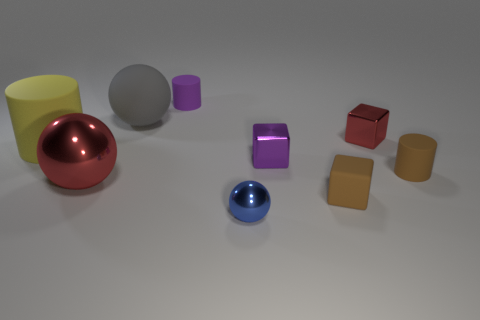Is the number of large shiny spheres behind the big gray sphere greater than the number of blue balls that are behind the tiny blue sphere?
Offer a very short reply. No. What number of things are matte objects behind the big yellow rubber thing or small brown shiny blocks?
Give a very brief answer. 2. The large red thing that is made of the same material as the blue sphere is what shape?
Your answer should be very brief. Sphere. Is there any other thing that is the same shape as the small red thing?
Ensure brevity in your answer.  Yes. What color is the cylinder that is in front of the big gray matte sphere and right of the gray matte ball?
Keep it short and to the point. Brown. What number of spheres are either big red metallic things or yellow rubber things?
Keep it short and to the point. 1. How many purple metal blocks are the same size as the gray matte thing?
Provide a succinct answer. 0. There is a small cylinder that is to the right of the tiny purple matte object; what number of blue metallic things are in front of it?
Keep it short and to the point. 1. There is a rubber cylinder that is right of the large shiny thing and behind the purple shiny thing; what is its size?
Your answer should be very brief. Small. Are there more small purple objects than small purple rubber objects?
Give a very brief answer. Yes. 